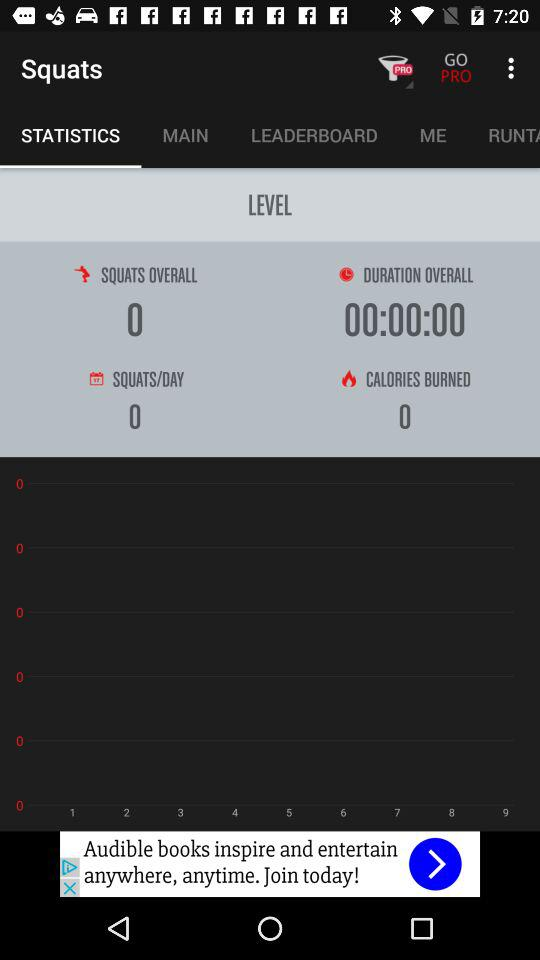What are the overall squats? The overall squats are 0. 